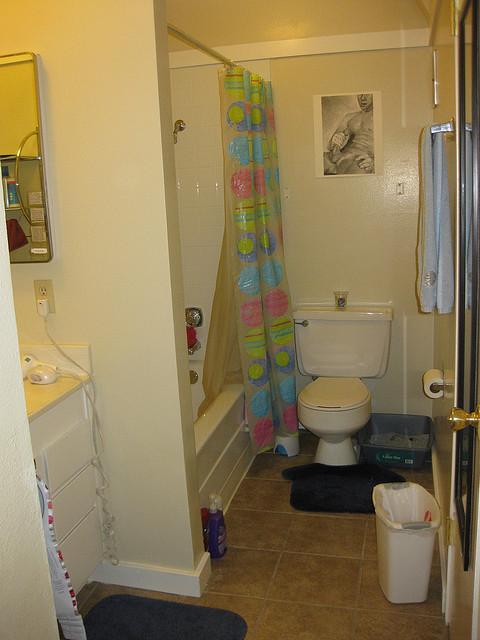Is the shower curtain closed?
Be succinct. No. Is there a window?
Keep it brief. No. What item is closest to the door?
Short answer required. Trash can. What room is in the picture?
Be succinct. Bathroom. What color are the towels?
Answer briefly. Blue. 